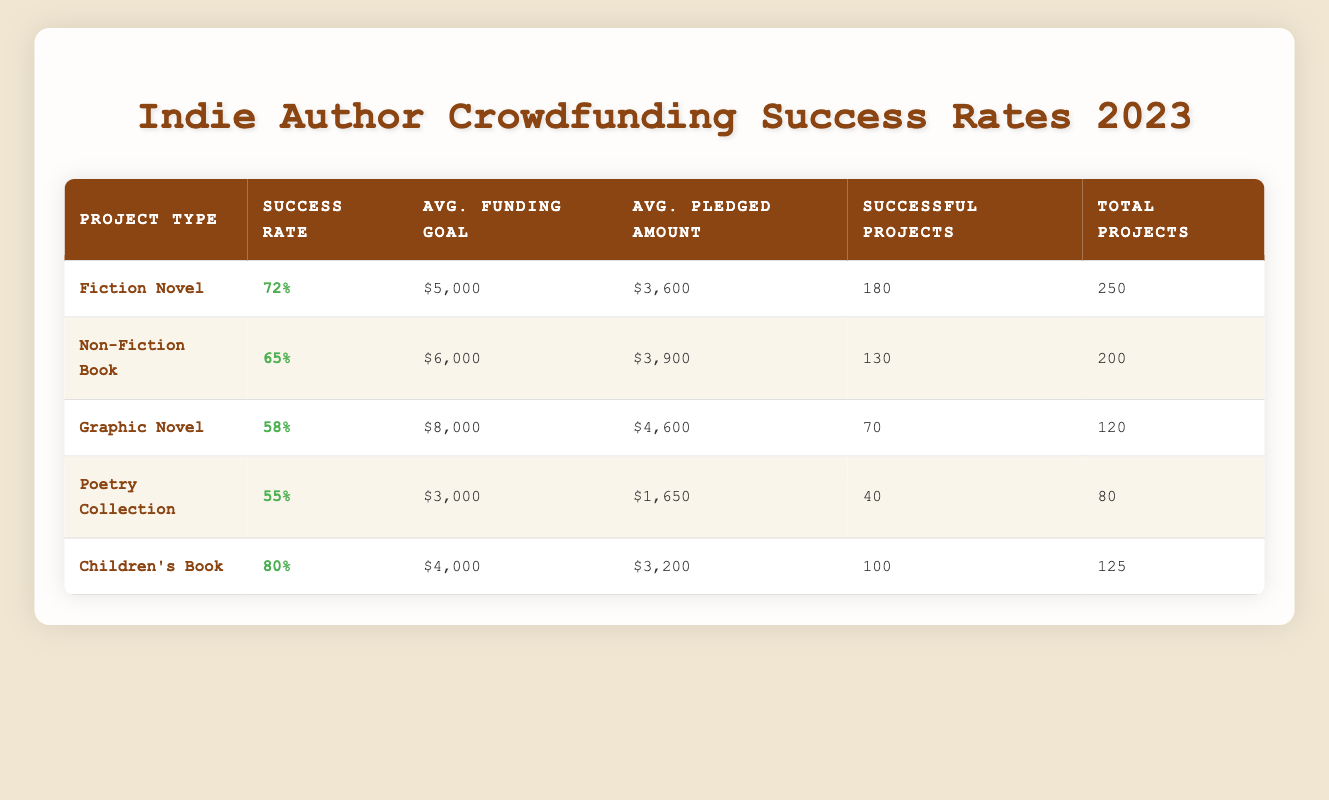What is the success rate percentage for Children's Books? The table shows that the success rate percentage for Children's Books is specified directly under the "Success Rate" column next to the project type. It indicates an 80% success rate.
Answer: 80% Which project type has the highest average pledged amount? By comparing the values in the "Avg. Pledged Amount" column, the highest amount is $4,600 for Graphic Novels, which is greater than the other project types.
Answer: Graphic Novel How many more successful projects were there for Fiction Novels compared to Poetry Collections? The number of successful projects for Fiction Novels is 180, and for Poetry Collections, it is 40. The difference is calculated as 180 - 40 = 140.
Answer: 140 Is the average funding goal for Non-Fiction Books higher than that for Children's Books? The average funding goal for Non-Fiction Books is $6,000, while for Children's Books, it is $4,000. A comparison shows that $6,000 is greater than $4,000.
Answer: Yes What is the average success rate percentage for all project types combined? We need to sum the success rates and divide by the number of project types. The total success rates are 72 + 65 + 58 + 55 + 80 = 330. There are 5 project types, so the average is 330 / 5 = 66.
Answer: 66 